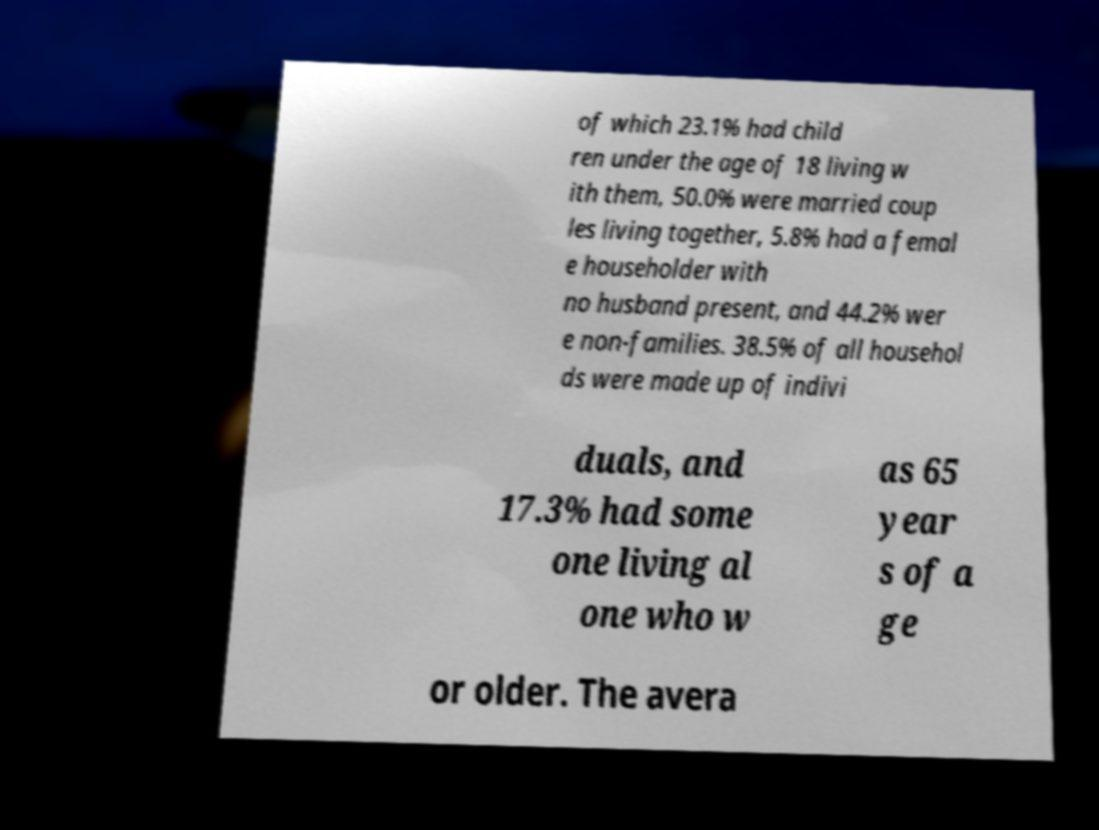There's text embedded in this image that I need extracted. Can you transcribe it verbatim? of which 23.1% had child ren under the age of 18 living w ith them, 50.0% were married coup les living together, 5.8% had a femal e householder with no husband present, and 44.2% wer e non-families. 38.5% of all househol ds were made up of indivi duals, and 17.3% had some one living al one who w as 65 year s of a ge or older. The avera 